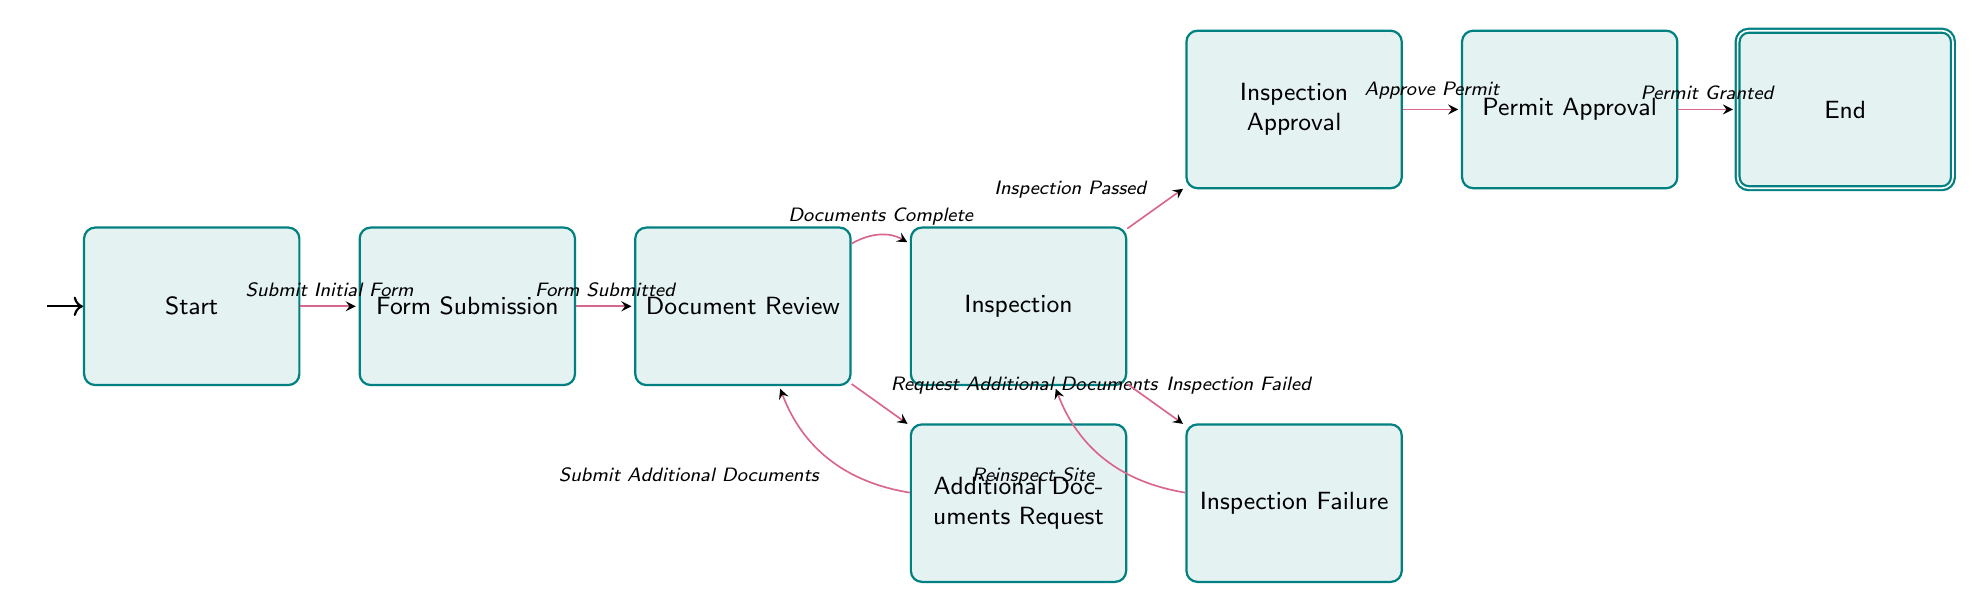What is the starting state of the permit application process? The diagram indicates that the starting state, labeled as "Start," is where the application process begins.
Answer: Start How many states are in the diagram? By counting the individual states listed in the diagram, we find that there are a total of eight distinct states represented.
Answer: 8 What event leads from "Form Submission" to "Document Review"? According to the diagram, the transition from "Form Submission" to "Document Review" occurs when the event "Form Submitted" takes place.
Answer: Form Submitted What condition leads to a request for additional documents? The diagram specifies that when the documents are deemed incomplete, the transition to "Additional Documents Request" happens under the condition "Documents Incomplete."
Answer: Documents Incomplete What happens if the inspection fails? If the inspection fails, the diagram shows that the process transitions back to "Inspection" for the event "Reinspect Site."
Answer: Reinspect Site What event is necessary for moving from "Inspection" to "Inspection Approval"? The event that allows transitioning from "Inspection" to "Inspection Approval" is labeled as "Inspection Passed" in the diagram.
Answer: Inspection Passed How many edges are there in the diagram? Counting the transitions depicted between states in the diagram, we find there are a total of ten edges connecting various states.
Answer: 10 What is the final state after the permit is granted? The last state in the sequence, which concludes the application process after the permit is granted, is labeled "End."
Answer: End What leads from "Document Review" to "Inspection"? The transition from "Document Review" to "Inspection" occurs when the documents are complete, indicated by the event "Documents Complete."
Answer: Documents Complete 